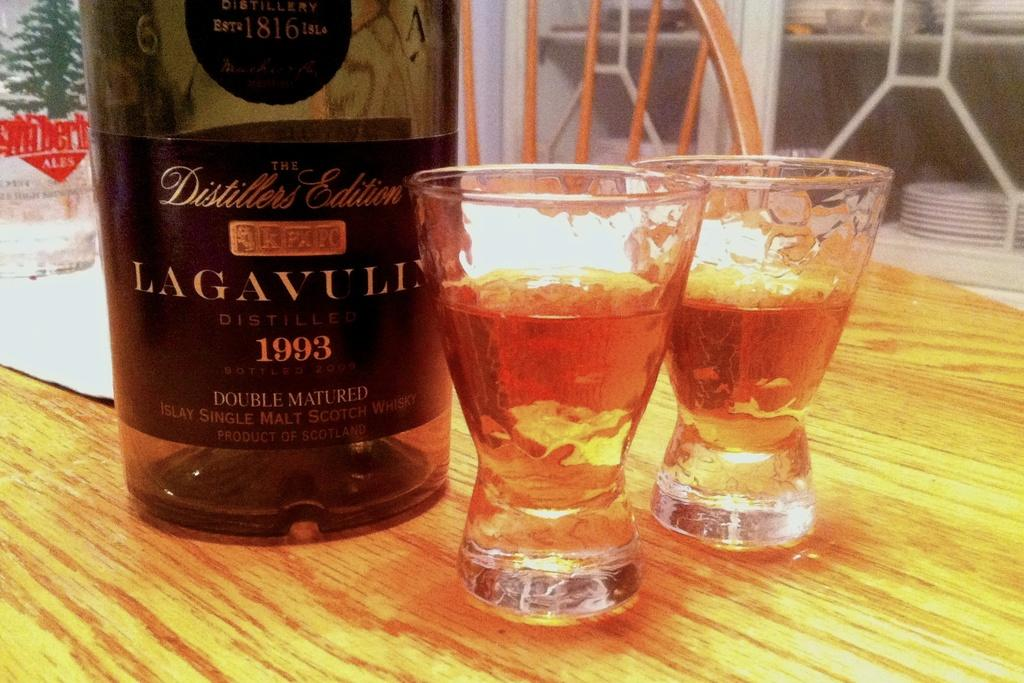<image>
Give a short and clear explanation of the subsequent image. Two glasses of liquor are sitting in front of a bottle of 1993 Lagavull on a table. 